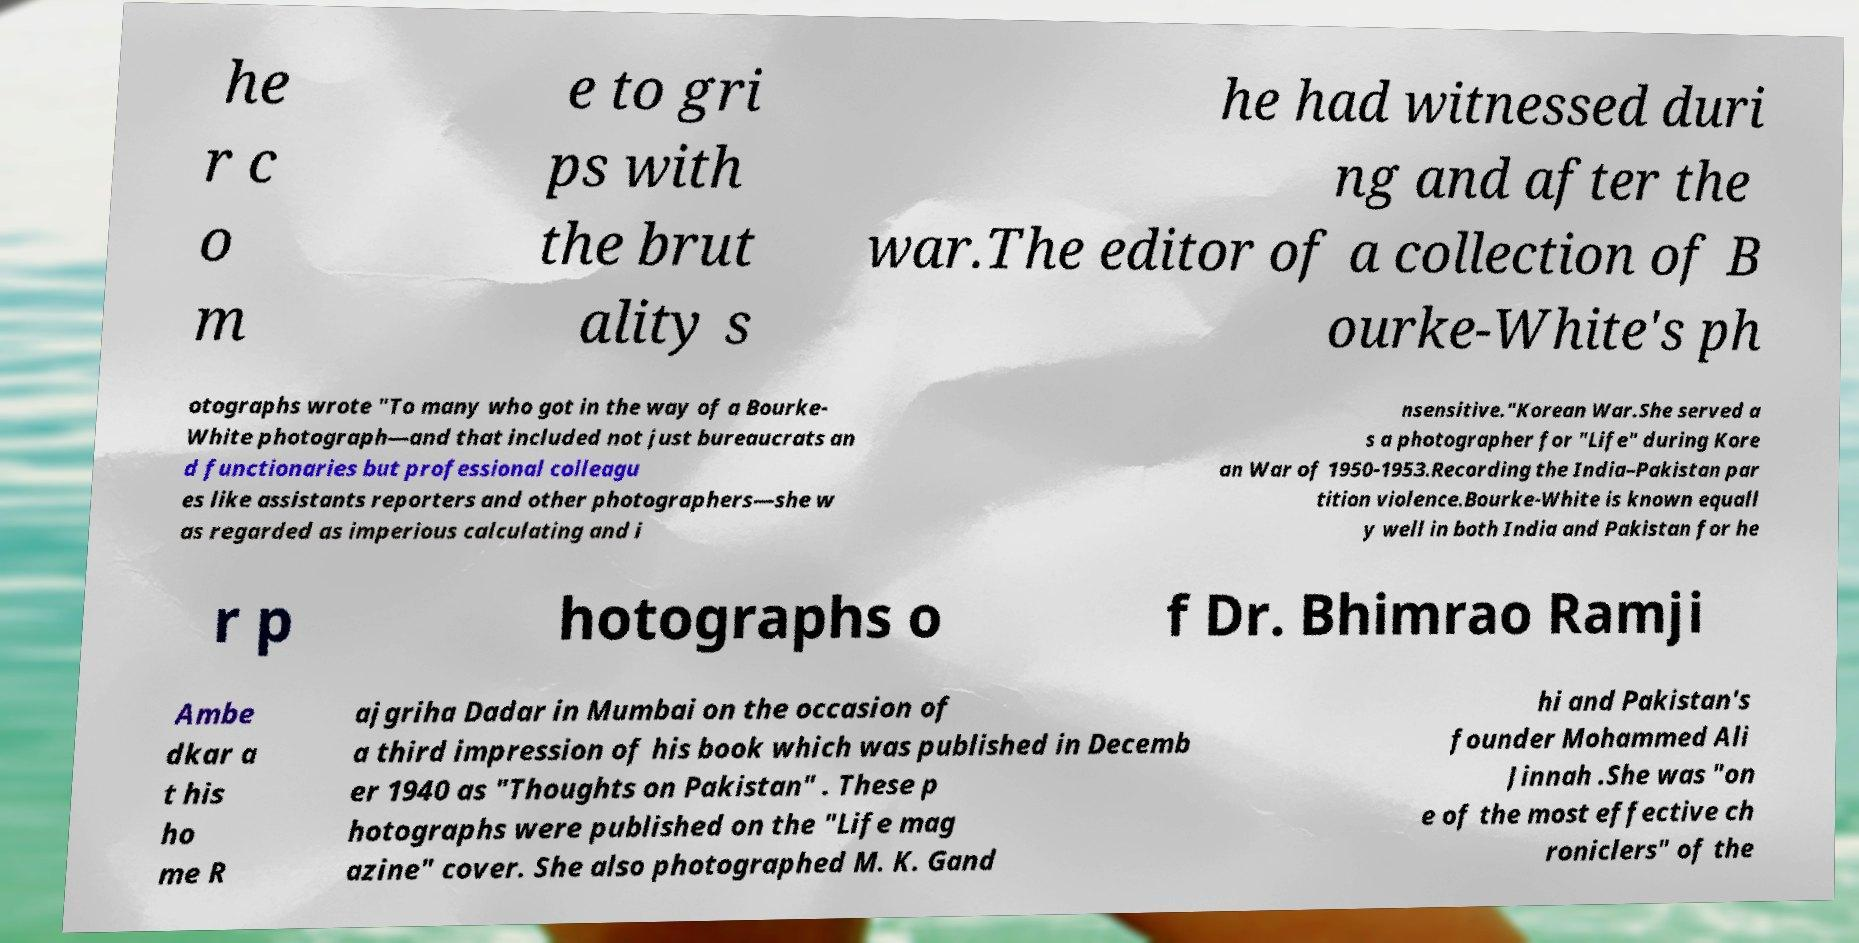Can you read and provide the text displayed in the image?This photo seems to have some interesting text. Can you extract and type it out for me? he r c o m e to gri ps with the brut ality s he had witnessed duri ng and after the war.The editor of a collection of B ourke-White's ph otographs wrote "To many who got in the way of a Bourke- White photograph—and that included not just bureaucrats an d functionaries but professional colleagu es like assistants reporters and other photographers—she w as regarded as imperious calculating and i nsensitive."Korean War.She served a s a photographer for "Life" during Kore an War of 1950-1953.Recording the India–Pakistan par tition violence.Bourke-White is known equall y well in both India and Pakistan for he r p hotographs o f Dr. Bhimrao Ramji Ambe dkar a t his ho me R ajgriha Dadar in Mumbai on the occasion of a third impression of his book which was published in Decemb er 1940 as "Thoughts on Pakistan" . These p hotographs were published on the "Life mag azine" cover. She also photographed M. K. Gand hi and Pakistan's founder Mohammed Ali Jinnah .She was "on e of the most effective ch roniclers" of the 